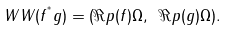<formula> <loc_0><loc_0><loc_500><loc_500>\ W W ( f ^ { ^ { * } } g ) = ( \Re p ( { f } ) \Omega , \ \Re p ( { g } ) \Omega ) .</formula> 